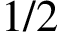Convert formula to latex. <formula><loc_0><loc_0><loc_500><loc_500>1 / 2</formula> 